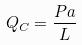<formula> <loc_0><loc_0><loc_500><loc_500>Q _ { C } = \frac { P a } { L }</formula> 